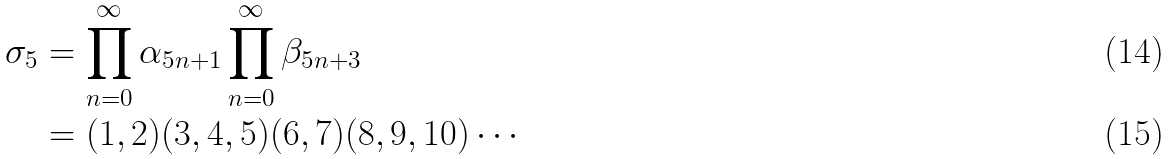Convert formula to latex. <formula><loc_0><loc_0><loc_500><loc_500>\sigma _ { 5 } & = \prod _ { n = 0 } ^ { \infty } \alpha _ { 5 n + 1 } \prod _ { n = 0 } ^ { \infty } \beta _ { 5 n + 3 } \\ & = ( 1 , 2 ) ( 3 , 4 , 5 ) ( 6 , 7 ) ( 8 , 9 , 1 0 ) \cdots</formula> 